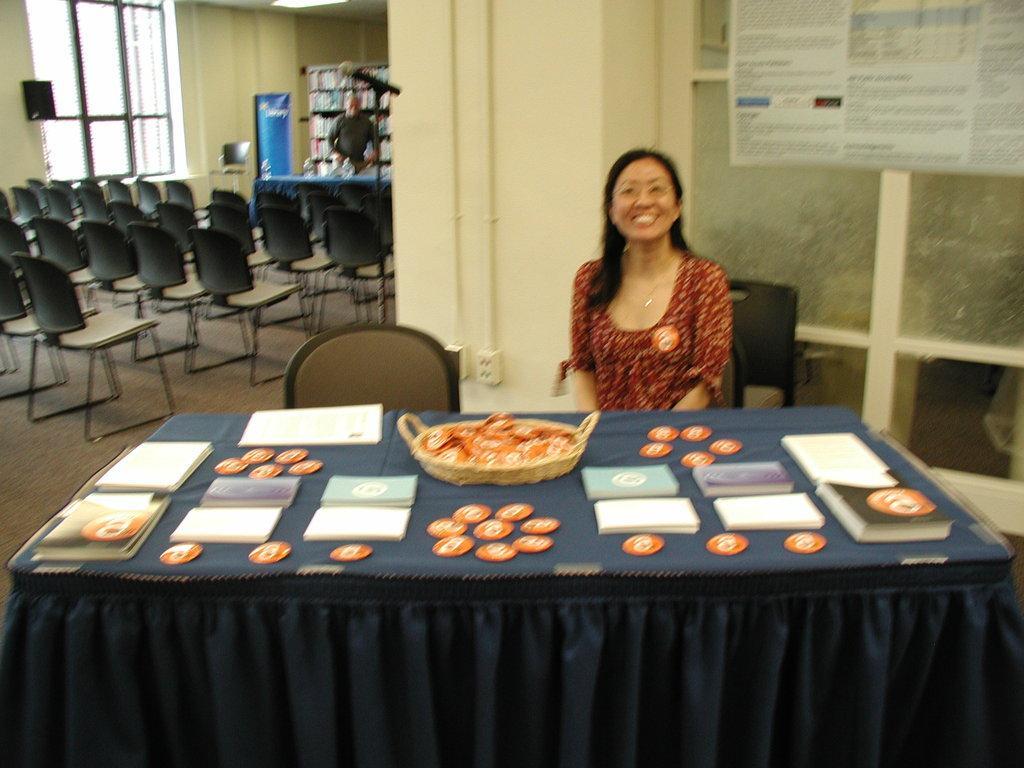In one or two sentences, can you explain what this image depicts? In this picture we can see a woman who is sitting on the chair. This is table. On the table there are books, cloth, and a basket. Here we can see some chairs. And there is a window. This is floor and there is a wall. 